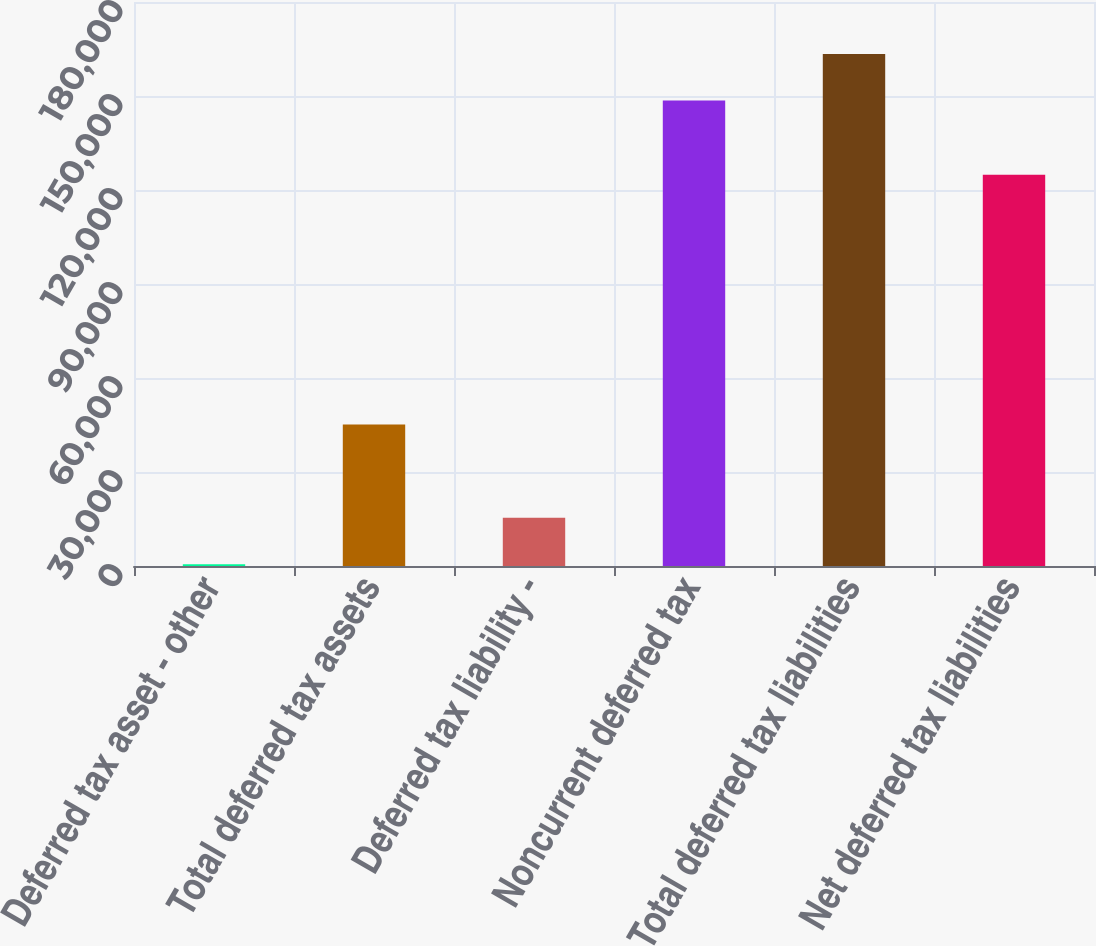<chart> <loc_0><loc_0><loc_500><loc_500><bar_chart><fcel>Deferred tax asset - other<fcel>Total deferred tax assets<fcel>Deferred tax liability -<fcel>Noncurrent deferred tax<fcel>Total deferred tax liabilities<fcel>Net deferred tax liabilities<nl><fcel>539<fcel>45154.4<fcel>15410.8<fcel>148534<fcel>163406<fcel>124889<nl></chart> 